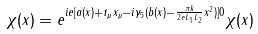<formula> <loc_0><loc_0><loc_500><loc_500>\chi ( x ) = e ^ { i e [ a ( x ) + t _ { \mu } x _ { \mu } - i \gamma _ { 5 } ( b ( x ) - \frac { \pi k } { 2 e L _ { 1 } L _ { 2 } } x ^ { 2 } ) ] 0 } \chi ( x )</formula> 